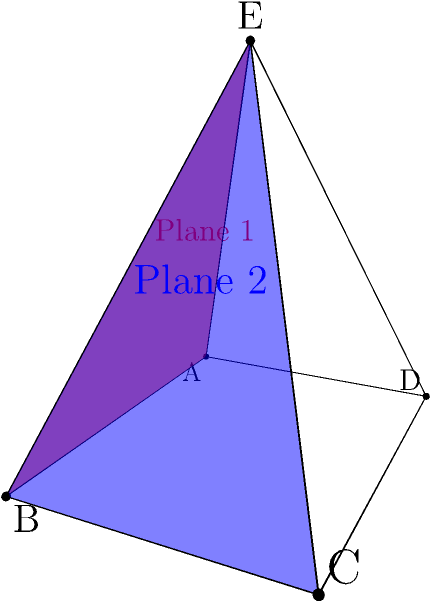In the church steeple represented by the diagram, two planes (shown in red and blue) intersect to form an edge of the steeple. Given that the base of the steeple is a 4m × 3m rectangle, and the apex is 4m above the center of the base, what is the angle between these two planes? To find the angle between the two planes, we can follow these steps:

1) First, we need to find the normal vectors of both planes. Let's call the red plane Plane 1 and the blue plane Plane 2.

2) For Plane 1:
   - Two vectors on this plane are $\vec{AB} = (4,0,0)$ and $\vec{AE} = (2,1.5,4)$
   - The normal vector $\vec{n_1} = \vec{AB} \times \vec{AE} = (0,16,-6)$

3) For Plane 2:
   - Two vectors on this plane are $\vec{BC} = (0,3,0)$ and $\vec{BE} = (-2,1.5,4)$
   - The normal vector $\vec{n_2} = \vec{BC} \times \vec{BE} = (12,8,-6)$

4) The angle between the planes is the same as the angle between their normal vectors. We can find this using the dot product formula:

   $$\cos \theta = \frac{\vec{n_1} \cdot \vec{n_2}}{|\vec{n_1}||\vec{n_2}|}$$

5) Calculate the dot product:
   $\vec{n_1} \cdot \vec{n_2} = 0(12) + 16(8) + (-6)(-6) = 164$

6) Calculate the magnitudes:
   $|\vec{n_1}| = \sqrt{0^2 + 16^2 + (-6)^2} = \sqrt{292}$
   $|\vec{n_2}| = \sqrt{12^2 + 8^2 + (-6)^2} = \sqrt{244}$

7) Substitute into the formula:
   $$\cos \theta = \frac{164}{\sqrt{292}\sqrt{244}} = \frac{164}{\sqrt{71248}} \approx 0.6144$$

8) Take the inverse cosine (arccos) of both sides:
   $$\theta = \arccos(0.6144) \approx 0.9151 \text{ radians} \approx 52.43°$$

Therefore, the angle between the two planes is approximately 52.43°.
Answer: $52.43°$ 